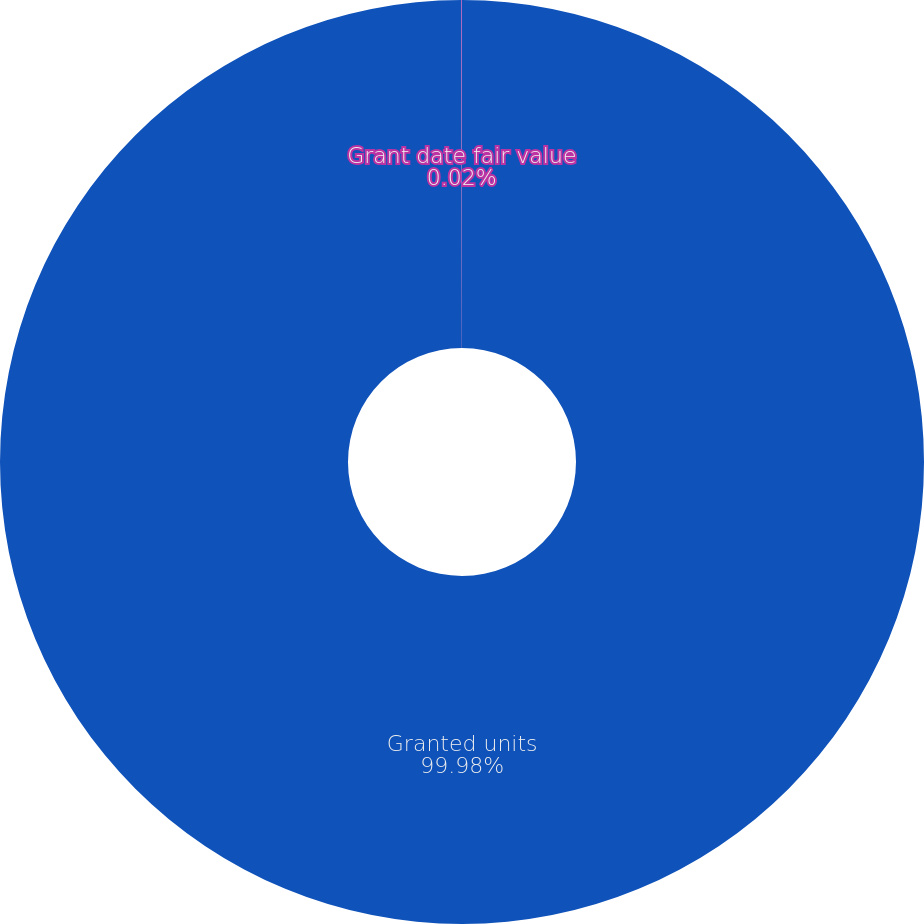<chart> <loc_0><loc_0><loc_500><loc_500><pie_chart><fcel>Granted units<fcel>Grant date fair value<nl><fcel>99.98%<fcel>0.02%<nl></chart> 